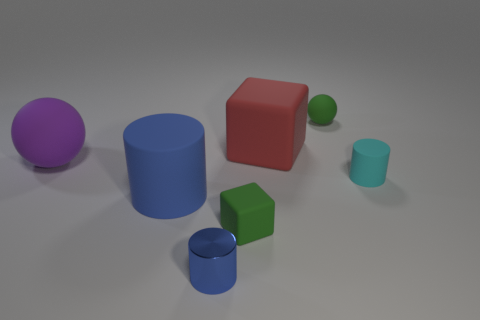Does the lighting in the image suggest a specific time of day or setting? The image appears to be a computer-generated rendering, rather than a natural setting. The lighting does not resemble natural sunlight but rather a neutral overhead light commonly used in rendering software to provide an even illumination. There are no shadows or highlights that would suggest a specific time of day. 